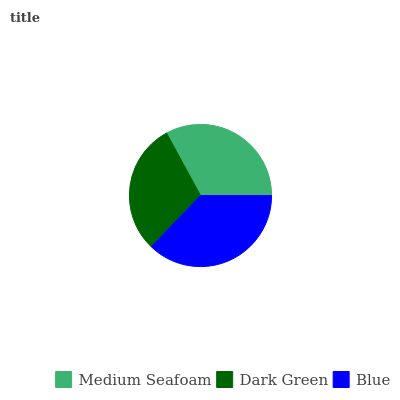Is Dark Green the minimum?
Answer yes or no. Yes. Is Blue the maximum?
Answer yes or no. Yes. Is Blue the minimum?
Answer yes or no. No. Is Dark Green the maximum?
Answer yes or no. No. Is Blue greater than Dark Green?
Answer yes or no. Yes. Is Dark Green less than Blue?
Answer yes or no. Yes. Is Dark Green greater than Blue?
Answer yes or no. No. Is Blue less than Dark Green?
Answer yes or no. No. Is Medium Seafoam the high median?
Answer yes or no. Yes. Is Medium Seafoam the low median?
Answer yes or no. Yes. Is Dark Green the high median?
Answer yes or no. No. Is Dark Green the low median?
Answer yes or no. No. 